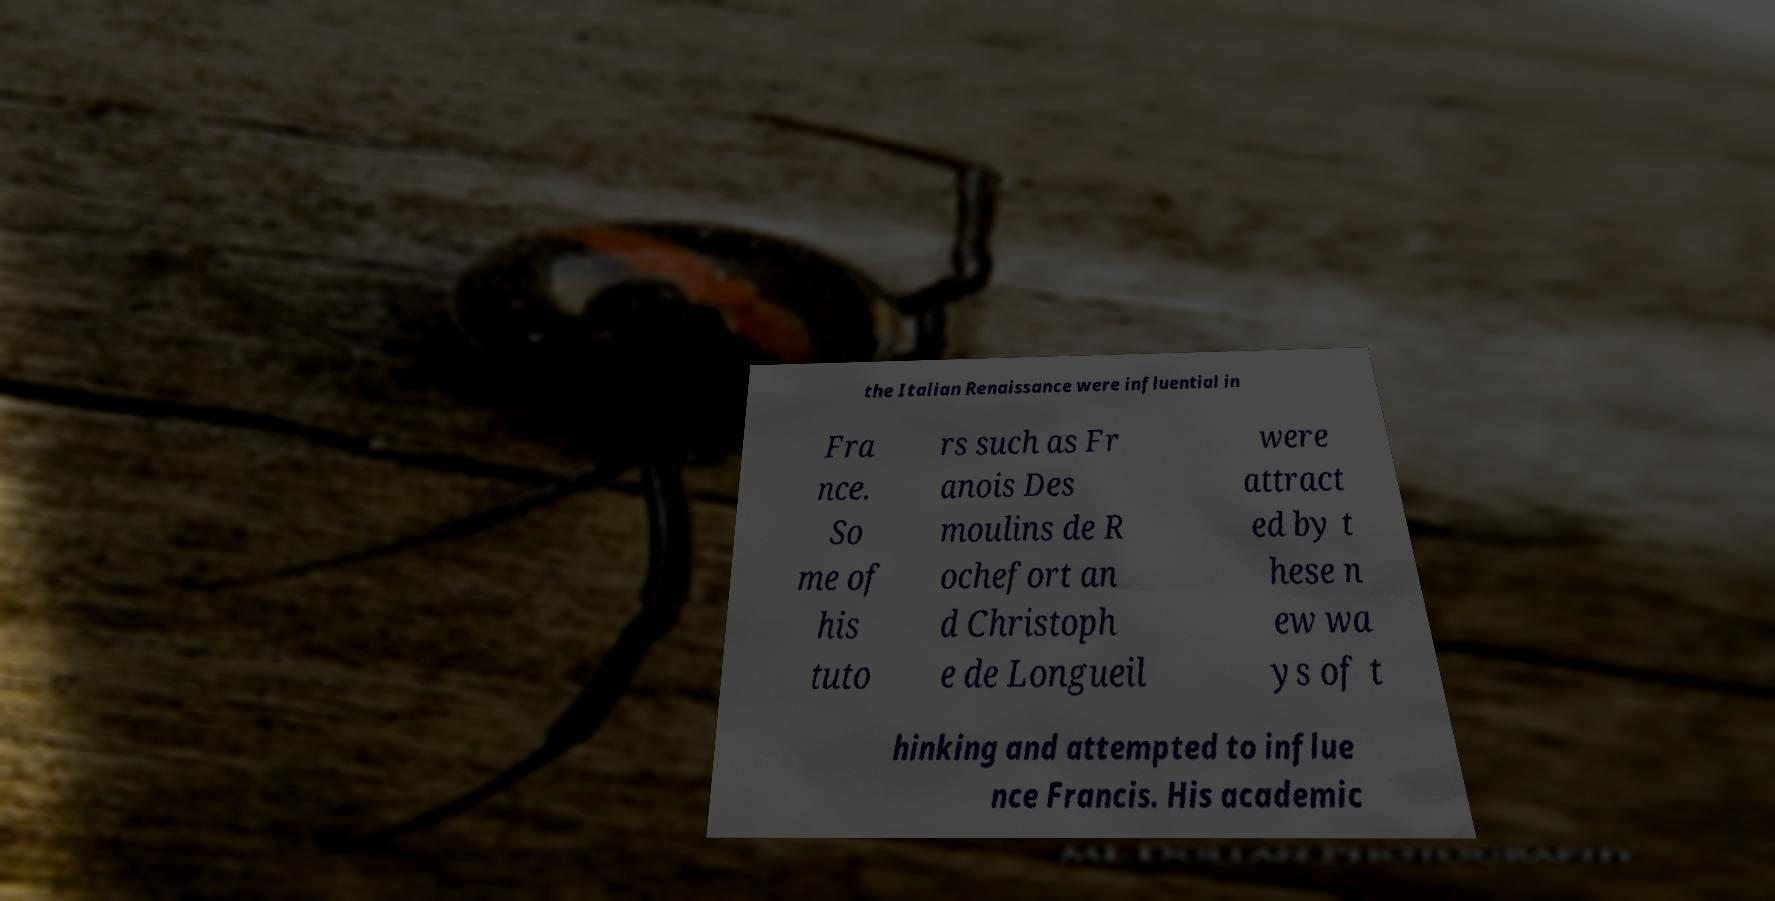For documentation purposes, I need the text within this image transcribed. Could you provide that? the Italian Renaissance were influential in Fra nce. So me of his tuto rs such as Fr anois Des moulins de R ochefort an d Christoph e de Longueil were attract ed by t hese n ew wa ys of t hinking and attempted to influe nce Francis. His academic 